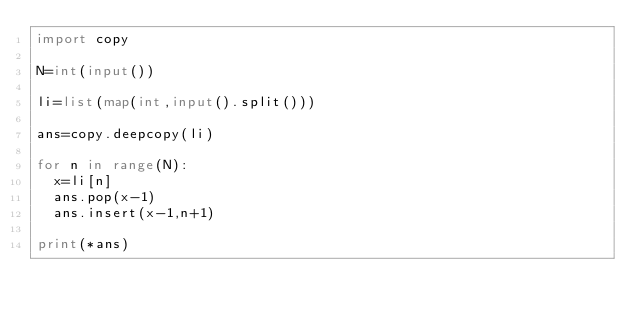<code> <loc_0><loc_0><loc_500><loc_500><_Python_>import copy

N=int(input())

li=list(map(int,input().split()))

ans=copy.deepcopy(li)

for n in range(N):
  x=li[n]
  ans.pop(x-1)
  ans.insert(x-1,n+1)

print(*ans)</code> 